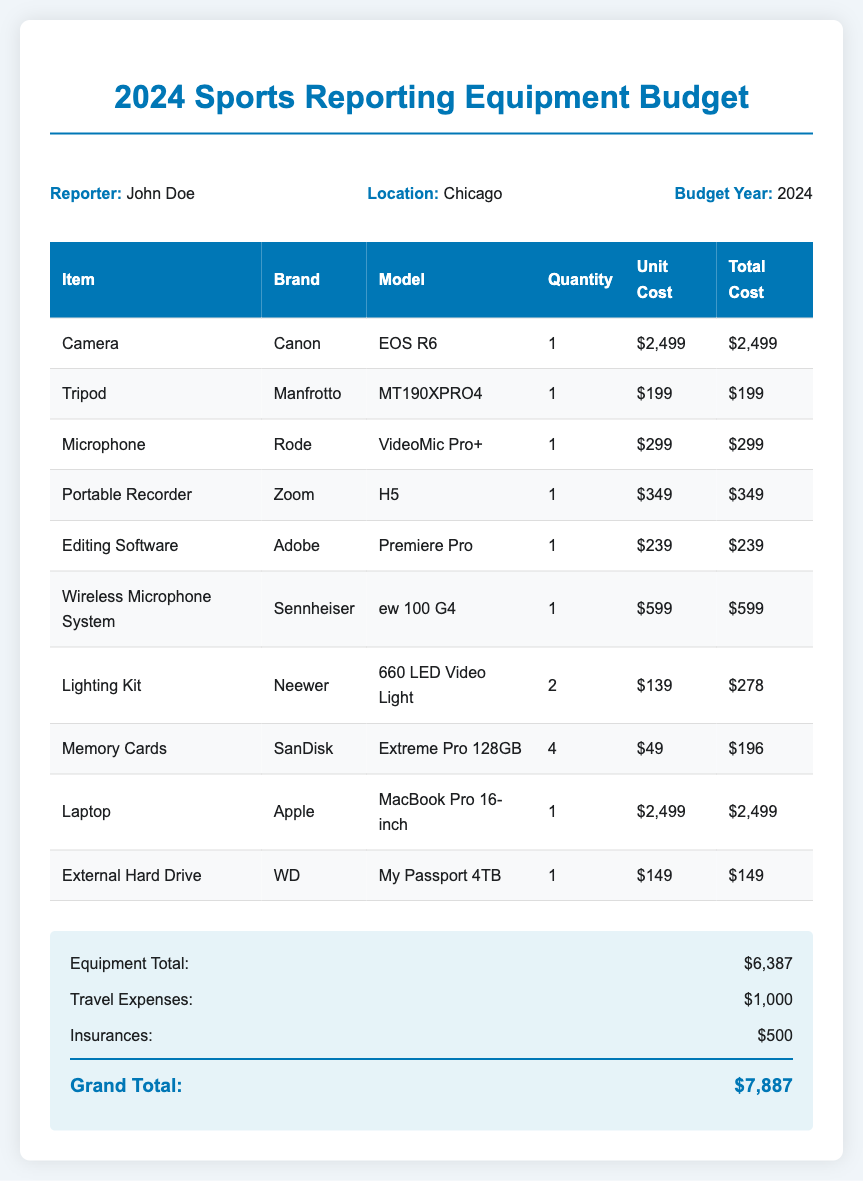what is the name of the reporter? The document specifies the reporter's name as John Doe.
Answer: John Doe what is the total cost of the camera? The total cost for the camera (Canon EOS R6) is listed as $2,499.
Answer: $2,499 how many memory cards are included in the budget? The budget itemizes four memory cards (SanDisk Extreme Pro 128GB) in the quantity column.
Answer: 4 what is the brand of the wireless microphone system? The brand listed for the wireless microphone system is Sennheiser.
Answer: Sennheiser what is the budget year mentioned in the document? The document specifies that the budget year is 2024.
Answer: 2024 how much are travel expenses listed in the budget? The document states that travel expenses amount to $1,000.
Answer: $1,000 what is the total equipment cost before travel and insurance? The total equipment cost is calculated as $6,387, which is stated in the document.
Answer: $6,387 which laptop model is included in the budget? The laptop specified is the MacBook Pro 16-inch by Apple.
Answer: MacBook Pro 16-inch what is the grand total of the budget? The grand total of the budget is given as $7,887.
Answer: $7,887 